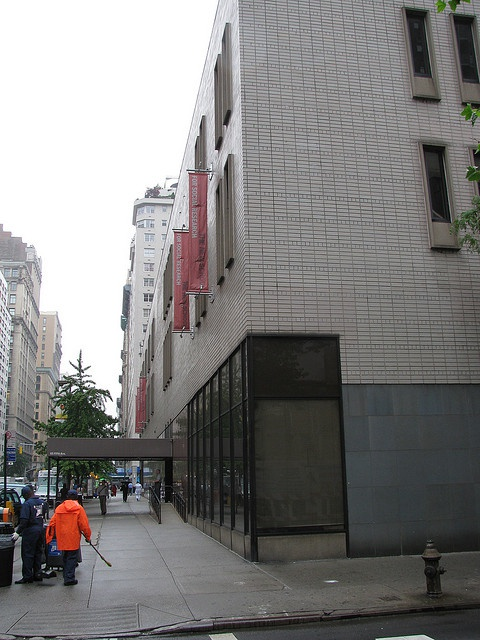Describe the objects in this image and their specific colors. I can see people in white, black, navy, gray, and darkgray tones, people in white, black, brown, and red tones, fire hydrant in white, black, and gray tones, car in white, black, gray, teal, and olive tones, and people in white, black, and gray tones in this image. 